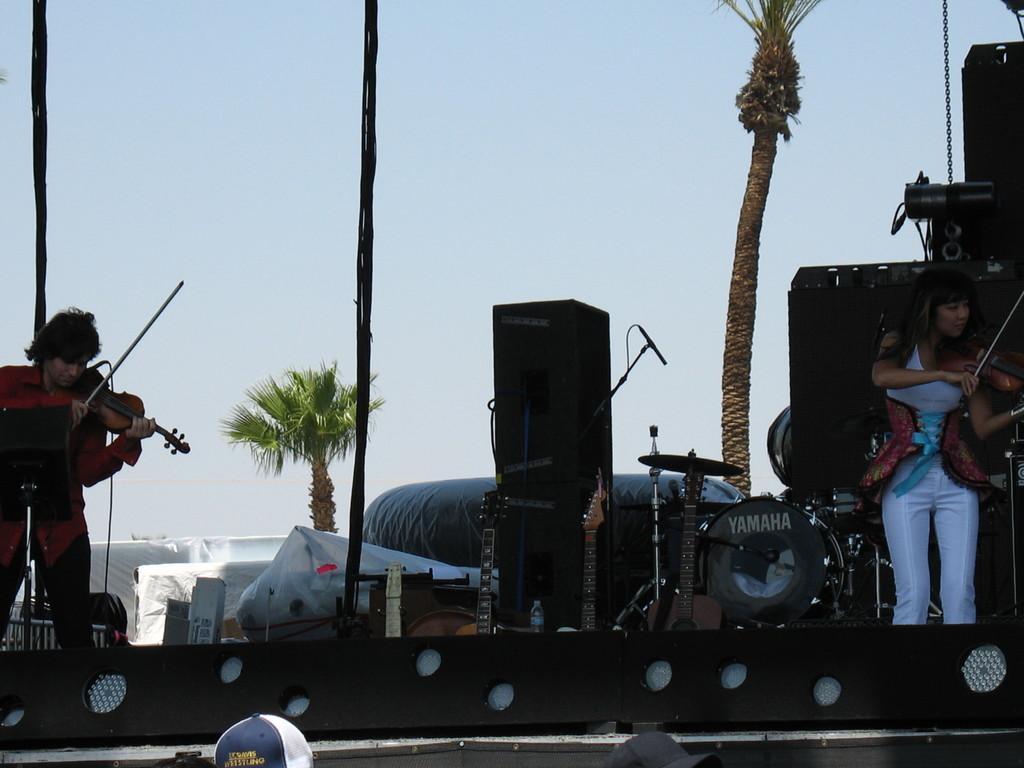Could you give a brief overview of what you see in this image? This picture describes about group of people in this image we can see two musicians playing musical instruments we can see couple of musical instruments in the background we see couple of trees. 